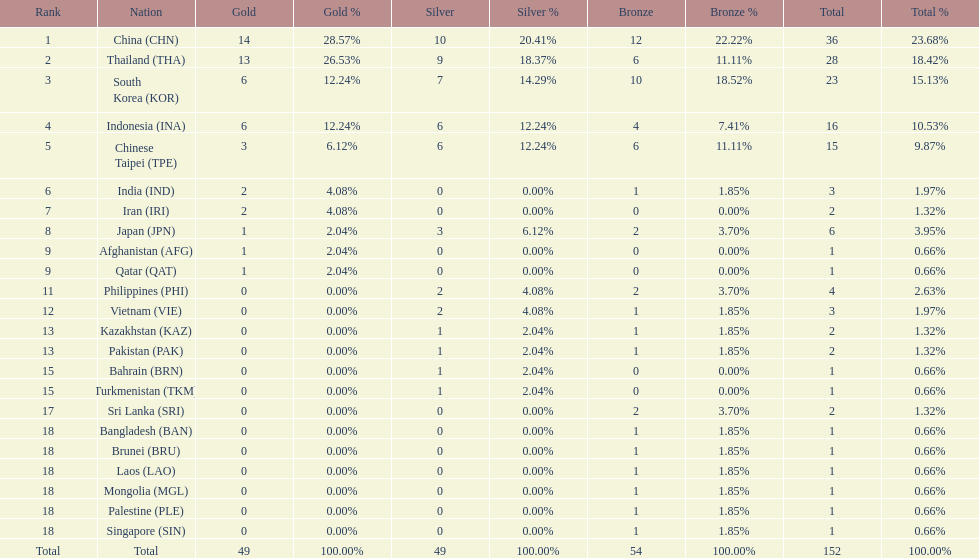Parse the table in full. {'header': ['Rank', 'Nation', 'Gold', 'Gold %', 'Silver', 'Silver %', 'Bronze', 'Bronze %', 'Total', 'Total %'], 'rows': [['1', 'China\xa0(CHN)', '14', '28.57%', '10', '20.41%', '12', '22.22%', '36', '23.68%'], ['2', 'Thailand\xa0(THA)', '13', '26.53%', '9', '18.37%', '6', '11.11%', '28', '18.42%'], ['3', 'South Korea\xa0(KOR)', '6', '12.24%', '7', '14.29%', '10', '18.52%', '23', '15.13%'], ['4', 'Indonesia\xa0(INA)', '6', '12.24%', '6', '12.24%', '4', '7.41%', '16', '10.53%'], ['5', 'Chinese Taipei\xa0(TPE)', '3', '6.12%', '6', '12.24%', '6', '11.11%', '15', '9.87%'], ['6', 'India\xa0(IND)', '2', '4.08%', '0', '0.00%', '1', '1.85%', '3', '1.97%'], ['7', 'Iran\xa0(IRI)', '2', '4.08%', '0', '0.00%', '0', '0.00%', '2', '1.32%'], ['8', 'Japan\xa0(JPN)', '1', '2.04%', '3', '6.12%', '2', '3.70%', '6', '3.95%'], ['9', 'Afghanistan\xa0(AFG)', '1', '2.04%', '0', '0.00%', '0', '0.00%', '1', '0.66%'], ['9', 'Qatar\xa0(QAT)', '1', '2.04%', '0', '0.00%', '0', '0.00%', '1', '0.66%'], ['11', 'Philippines\xa0(PHI)', '0', '0.00%', '2', '4.08%', '2', '3.70%', '4', '2.63%'], ['12', 'Vietnam\xa0(VIE)', '0', '0.00%', '2', '4.08%', '1', '1.85%', '3', '1.97%'], ['13', 'Kazakhstan\xa0(KAZ)', '0', '0.00%', '1', '2.04%', '1', '1.85%', '2', '1.32%'], ['13', 'Pakistan\xa0(PAK)', '0', '0.00%', '1', '2.04%', '1', '1.85%', '2', '1.32%'], ['15', 'Bahrain\xa0(BRN)', '0', '0.00%', '1', '2.04%', '0', '0.00%', '1', '0.66%'], ['15', 'Turkmenistan\xa0(TKM)', '0', '0.00%', '1', '2.04%', '0', '0.00%', '1', '0.66%'], ['17', 'Sri Lanka\xa0(SRI)', '0', '0.00%', '0', '0.00%', '2', '3.70%', '2', '1.32%'], ['18', 'Bangladesh\xa0(BAN)', '0', '0.00%', '0', '0.00%', '1', '1.85%', '1', '0.66%'], ['18', 'Brunei\xa0(BRU)', '0', '0.00%', '0', '0.00%', '1', '1.85%', '1', '0.66%'], ['18', 'Laos\xa0(LAO)', '0', '0.00%', '0', '0.00%', '1', '1.85%', '1', '0.66%'], ['18', 'Mongolia\xa0(MGL)', '0', '0.00%', '0', '0.00%', '1', '1.85%', '1', '0.66%'], ['18', 'Palestine\xa0(PLE)', '0', '0.00%', '0', '0.00%', '1', '1.85%', '1', '0.66%'], ['18', 'Singapore\xa0(SIN)', '0', '0.00%', '0', '0.00%', '1', '1.85%', '1', '0.66%'], ['Total', 'Total', '49', '100.00%', '49', '100.00%', '54', '100.00%', '152', '100.00%']]} What is the total number of nations that participated in the beach games of 2012? 23. 